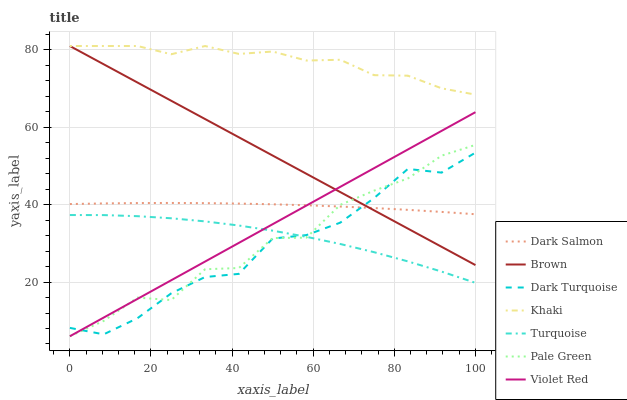Does Dark Turquoise have the minimum area under the curve?
Answer yes or no. Yes. Does Khaki have the maximum area under the curve?
Answer yes or no. Yes. Does Turquoise have the minimum area under the curve?
Answer yes or no. No. Does Turquoise have the maximum area under the curve?
Answer yes or no. No. Is Violet Red the smoothest?
Answer yes or no. Yes. Is Pale Green the roughest?
Answer yes or no. Yes. Is Turquoise the smoothest?
Answer yes or no. No. Is Turquoise the roughest?
Answer yes or no. No. Does Violet Red have the lowest value?
Answer yes or no. Yes. Does Turquoise have the lowest value?
Answer yes or no. No. Does Khaki have the highest value?
Answer yes or no. Yes. Does Turquoise have the highest value?
Answer yes or no. No. Is Turquoise less than Dark Salmon?
Answer yes or no. Yes. Is Khaki greater than Dark Salmon?
Answer yes or no. Yes. Does Pale Green intersect Dark Turquoise?
Answer yes or no. Yes. Is Pale Green less than Dark Turquoise?
Answer yes or no. No. Is Pale Green greater than Dark Turquoise?
Answer yes or no. No. Does Turquoise intersect Dark Salmon?
Answer yes or no. No. 